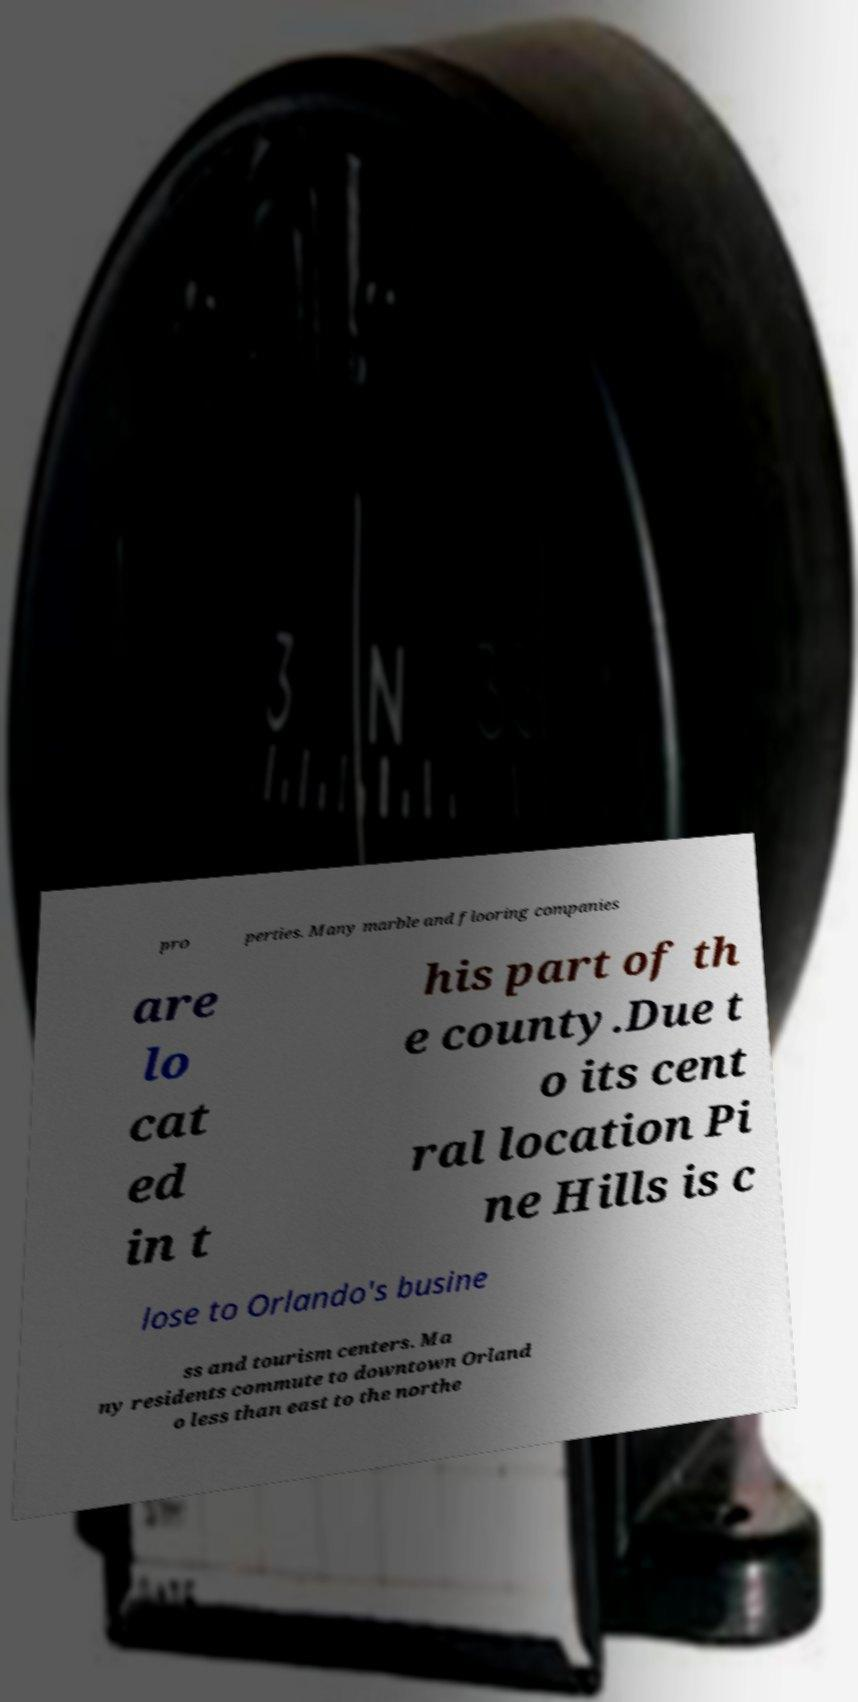There's text embedded in this image that I need extracted. Can you transcribe it verbatim? pro perties. Many marble and flooring companies are lo cat ed in t his part of th e county.Due t o its cent ral location Pi ne Hills is c lose to Orlando's busine ss and tourism centers. Ma ny residents commute to downtown Orland o less than east to the northe 